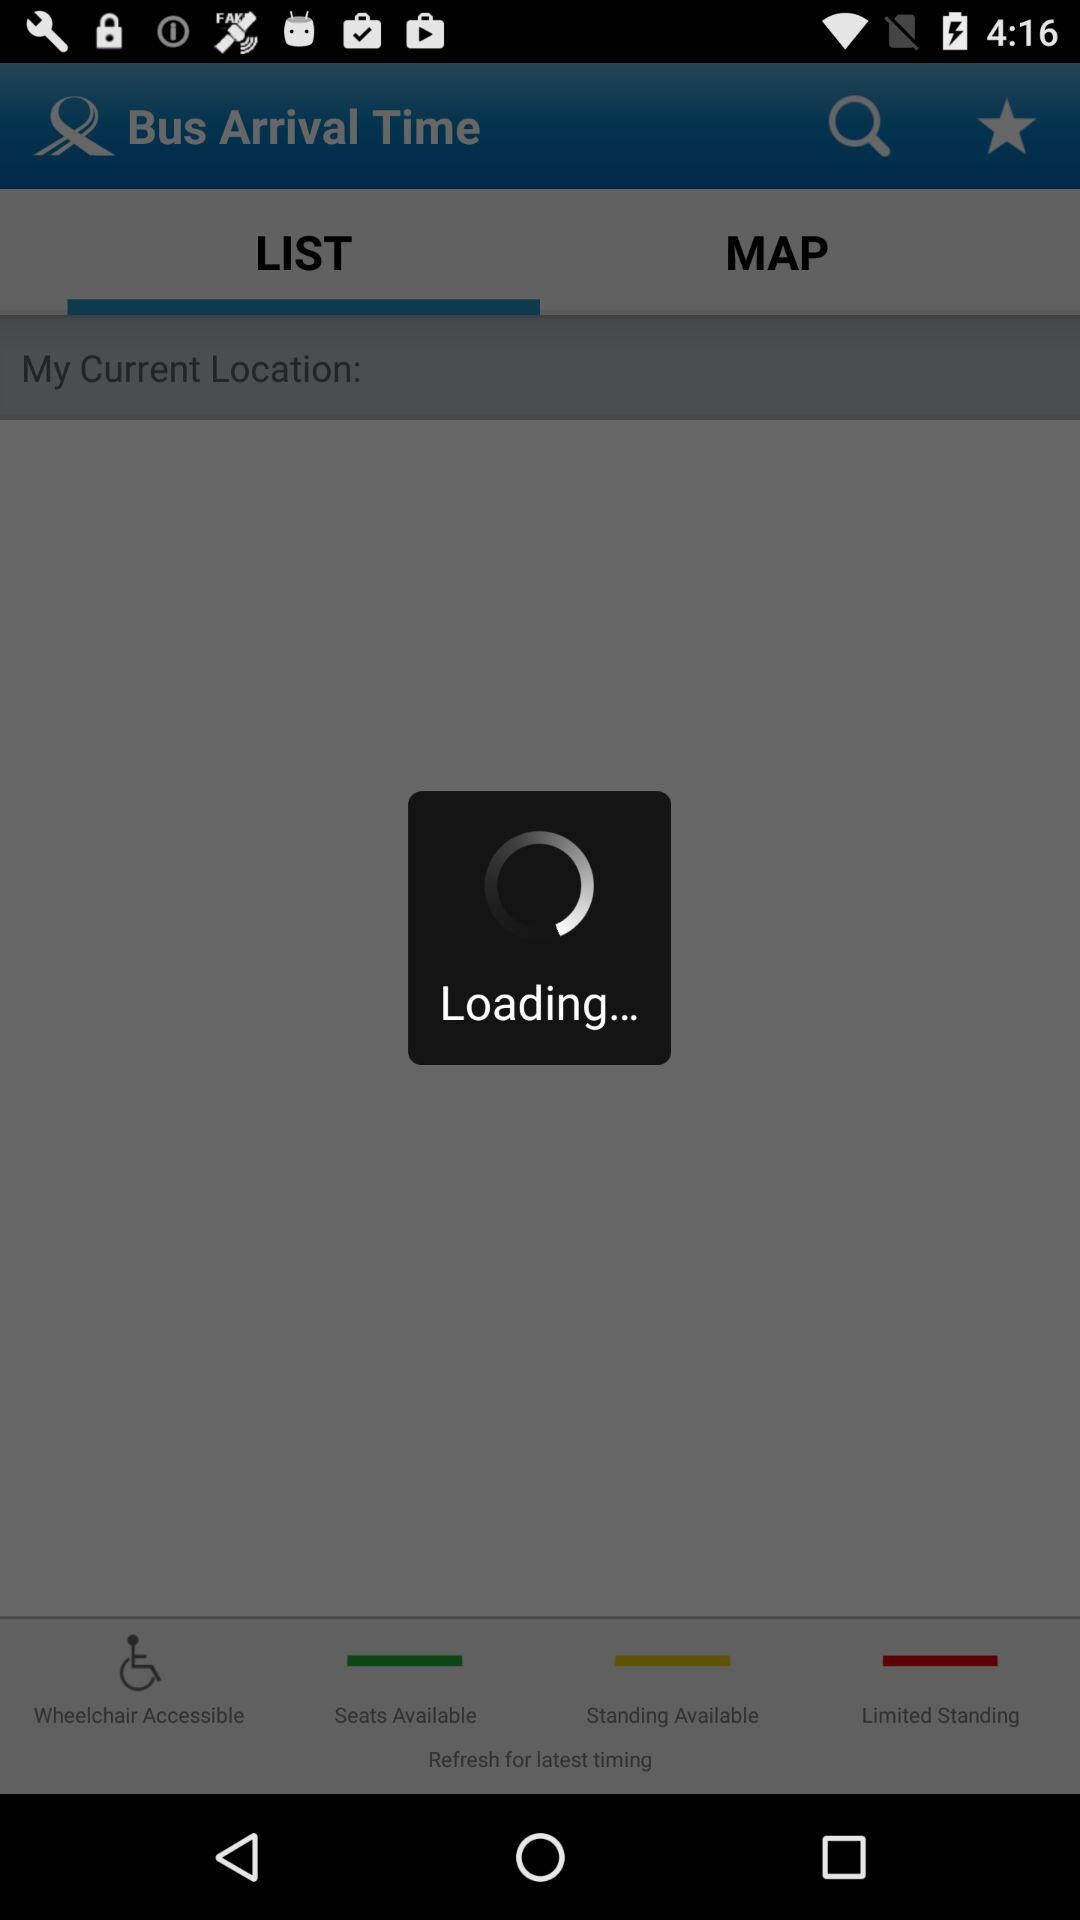Which tab is currently selected? The selected tab is "LIST". 